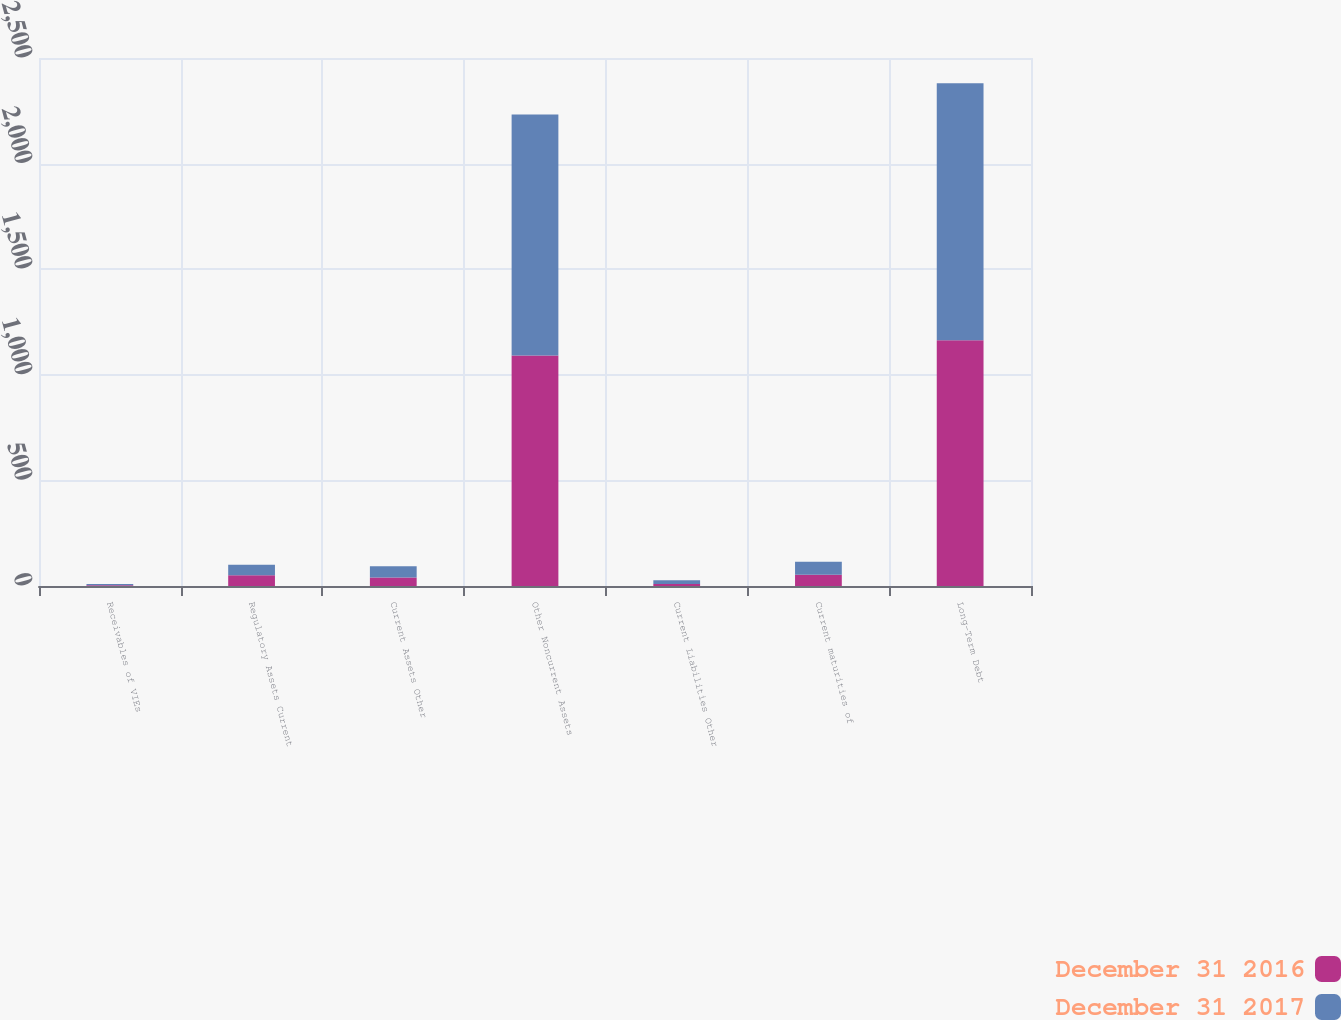Convert chart to OTSL. <chart><loc_0><loc_0><loc_500><loc_500><stacked_bar_chart><ecel><fcel>Receivables of VIEs<fcel>Regulatory Assets Current<fcel>Current Assets Other<fcel>Other Noncurrent Assets<fcel>Current Liabilities Other<fcel>Current maturities of<fcel>Long-Term Debt<nl><fcel>December 31 2016<fcel>4<fcel>51<fcel>40<fcel>1091<fcel>10<fcel>53<fcel>1164<nl><fcel>December 31 2017<fcel>6<fcel>50<fcel>53<fcel>1142<fcel>17<fcel>62<fcel>1217<nl></chart> 